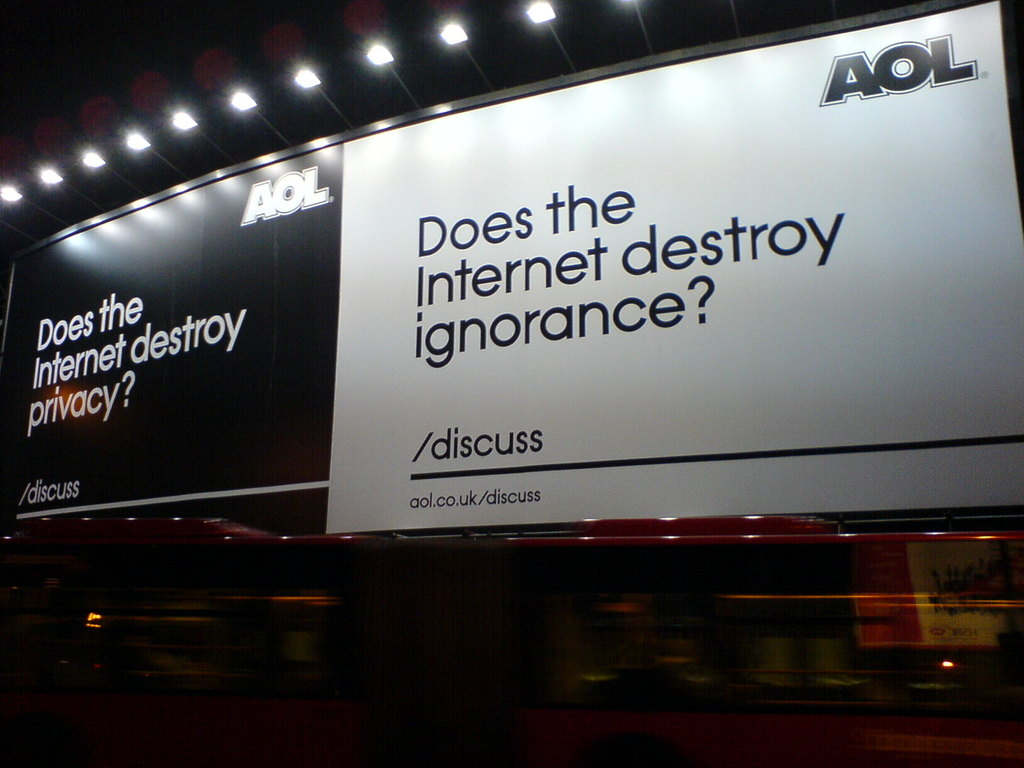What might be the implications of saying the Internet destroys privacy? Claiming that the Internet destroys privacy suggests that the pervasive nature of online data collection and surveillance can lead to a significant reduction in personal privacy. It raises concerns about how data is tracked, stored, and used, potentially without the explicit consent of individuals. This perspective prompts discussions on the need for robust privacy protections and regulations to safeguard personal information in the digital age. 